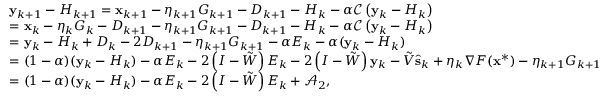Convert formula to latex. <formula><loc_0><loc_0><loc_500><loc_500>\begin{array} { r l } & { y _ { k + 1 } - H _ { k + 1 } = x _ { k + 1 } - \eta _ { k + 1 } G _ { k + 1 } - { D } _ { k + 1 } - H _ { k } - \alpha \mathcal { C } \left ( y _ { k } - H _ { k } \right ) } \\ & { = x _ { k } - \eta _ { k } G _ { k } - { D } _ { k + 1 } - \eta _ { k + 1 } G _ { k + 1 } - { D } _ { k + 1 } - H _ { k } - \alpha \mathcal { C } \left ( y _ { k } - H _ { k } \right ) } \\ & { = y _ { k } - H _ { k } + { D } _ { k } - 2 { D } _ { k + 1 } - \eta _ { k + 1 } G _ { k + 1 } - \alpha E _ { k } - \alpha ( y _ { k } - H _ { k } ) } \\ & { = ( 1 - \alpha ) ( y _ { k } - H _ { k } ) - \alpha E _ { k } - 2 \left ( I - \tilde { W } \right ) E _ { k } - 2 \left ( I - \tilde { W } \right ) y _ { k } - \tilde { V } \hat { s } _ { k } + \eta _ { k } \nabla F ( x ^ { * } ) - \eta _ { k + 1 } G _ { k + 1 } } \\ & { = ( 1 - \alpha ) ( y _ { k } - H _ { k } ) - \alpha E _ { k } - 2 \left ( I - \tilde { W } \right ) E _ { k } + \mathcal { A } _ { 2 } , } \end{array}</formula> 